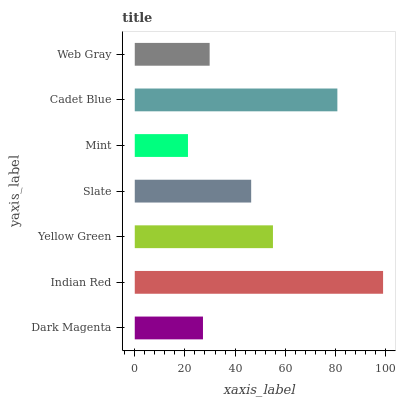Is Mint the minimum?
Answer yes or no. Yes. Is Indian Red the maximum?
Answer yes or no. Yes. Is Yellow Green the minimum?
Answer yes or no. No. Is Yellow Green the maximum?
Answer yes or no. No. Is Indian Red greater than Yellow Green?
Answer yes or no. Yes. Is Yellow Green less than Indian Red?
Answer yes or no. Yes. Is Yellow Green greater than Indian Red?
Answer yes or no. No. Is Indian Red less than Yellow Green?
Answer yes or no. No. Is Slate the high median?
Answer yes or no. Yes. Is Slate the low median?
Answer yes or no. Yes. Is Cadet Blue the high median?
Answer yes or no. No. Is Indian Red the low median?
Answer yes or no. No. 